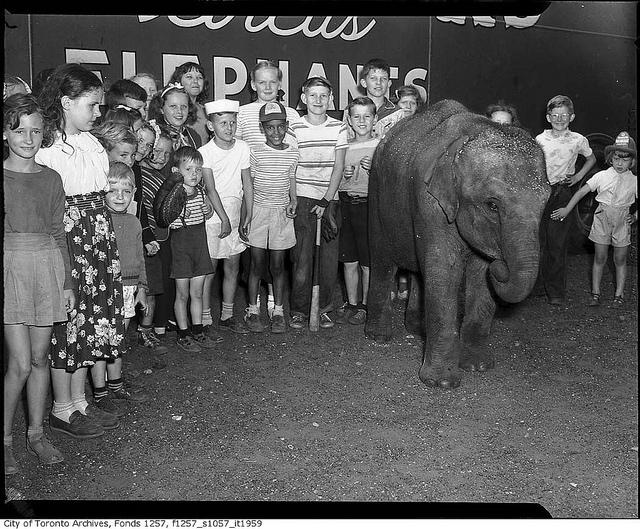What is the elephants trunk doing? curling 